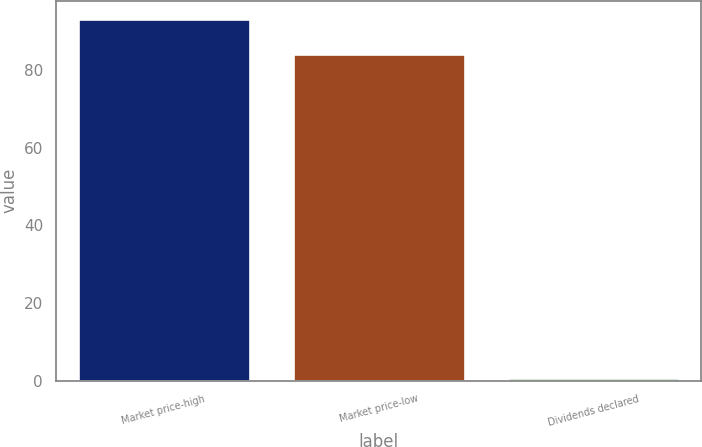Convert chart to OTSL. <chart><loc_0><loc_0><loc_500><loc_500><bar_chart><fcel>Market price-high<fcel>Market price-low<fcel>Dividends declared<nl><fcel>93.24<fcel>84.25<fcel>0.6<nl></chart> 